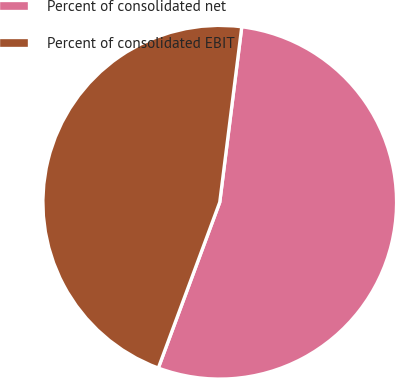Convert chart to OTSL. <chart><loc_0><loc_0><loc_500><loc_500><pie_chart><fcel>Percent of consolidated net<fcel>Percent of consolidated EBIT<nl><fcel>53.66%<fcel>46.34%<nl></chart> 